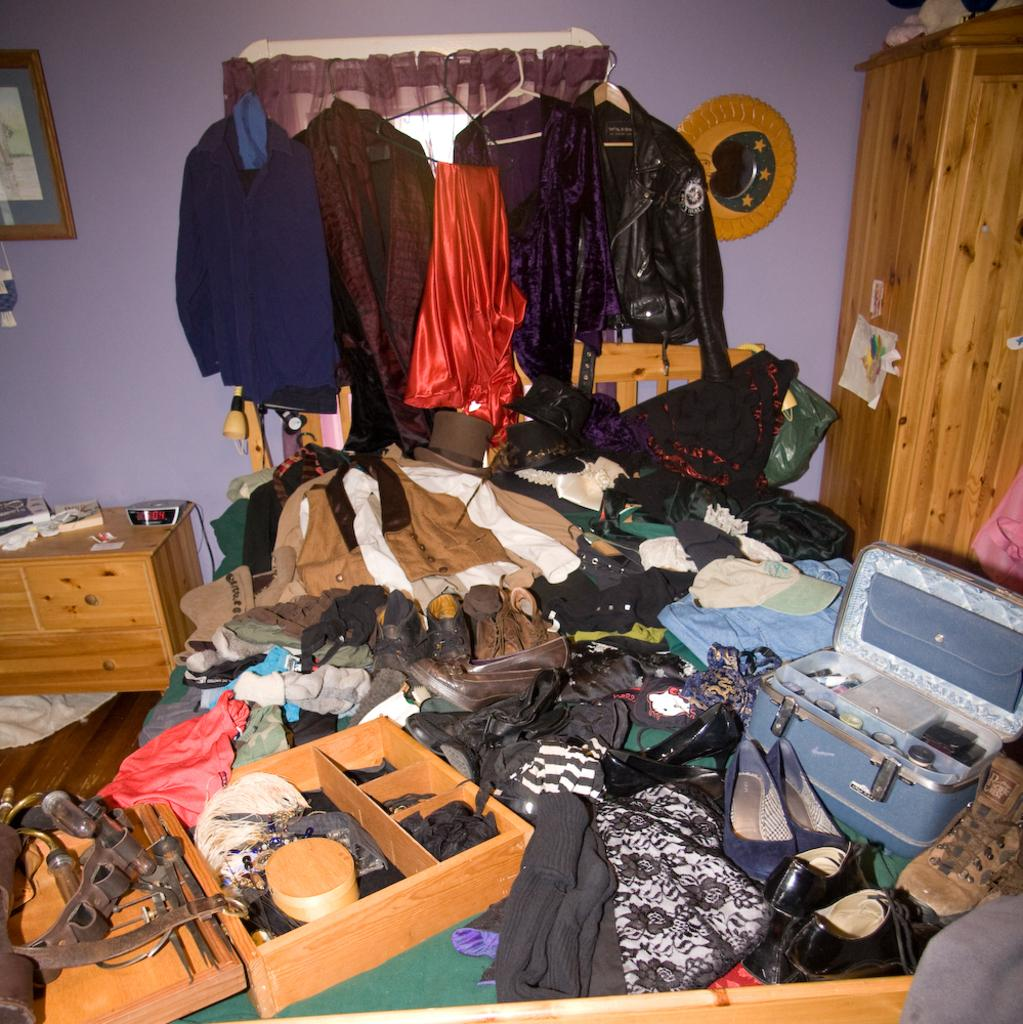What can be seen hanging in the image? There are clothes on hanging rods in the image. What is on the wall in the image? There are objects on the wall in the image, including clothes, footwear, tools, wooden objects, and other objects. Is there a swing visible in the image? No, there is no swing present in the image. 